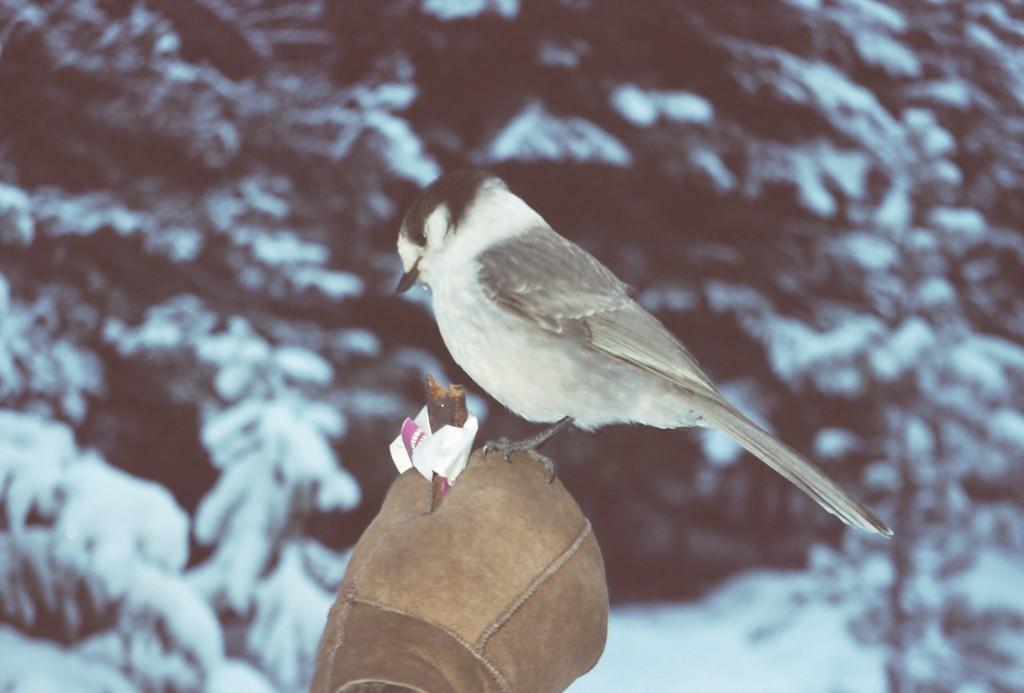How would you summarize this image in a sentence or two? A bird is sitting on the glove, there are trees with snow on it. 